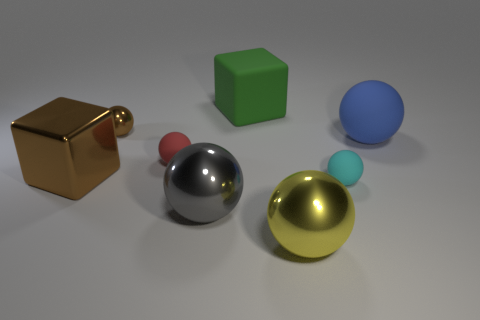There is a large metallic sphere that is on the right side of the block that is behind the small matte thing that is on the left side of the matte block; what is its color? The large metallic sphere situated to the right of the block, and behind the small matte object left of the matte block, displays a vibrant yellow color. 